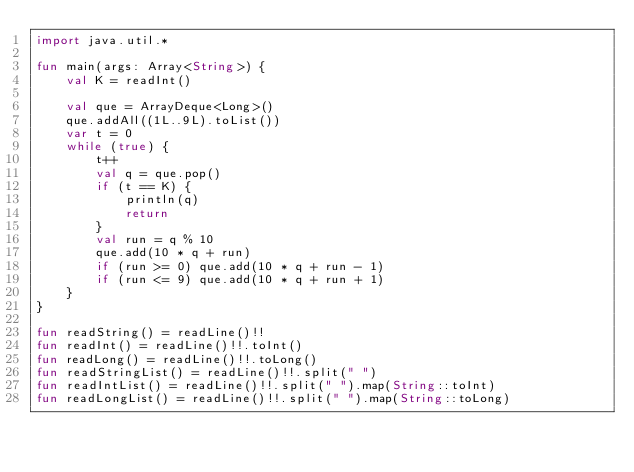<code> <loc_0><loc_0><loc_500><loc_500><_Kotlin_>import java.util.*

fun main(args: Array<String>) {
    val K = readInt()

    val que = ArrayDeque<Long>()
    que.addAll((1L..9L).toList())
    var t = 0
    while (true) {
        t++
        val q = que.pop()
        if (t == K) {
            println(q)
            return
        }
        val run = q % 10
        que.add(10 * q + run)
        if (run >= 0) que.add(10 * q + run - 1)
        if (run <= 9) que.add(10 * q + run + 1)
    }
}

fun readString() = readLine()!!
fun readInt() = readLine()!!.toInt()
fun readLong() = readLine()!!.toLong()
fun readStringList() = readLine()!!.split(" ")
fun readIntList() = readLine()!!.split(" ").map(String::toInt)
fun readLongList() = readLine()!!.split(" ").map(String::toLong)</code> 